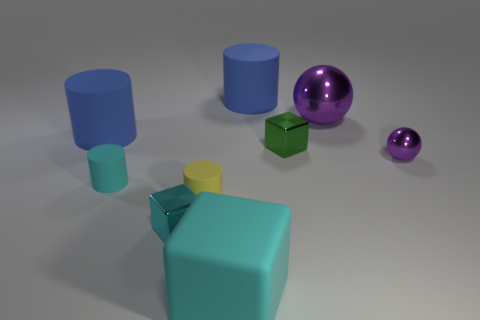Subtract all cyan cylinders. How many cylinders are left? 3 Add 1 cyan cubes. How many objects exist? 10 Subtract all green blocks. How many blocks are left? 2 Subtract 1 cylinders. How many cylinders are left? 3 Subtract all yellow spheres. Subtract all brown cylinders. How many spheres are left? 2 Subtract all red spheres. How many yellow cylinders are left? 1 Subtract all cyan rubber objects. Subtract all tiny yellow things. How many objects are left? 6 Add 5 small green blocks. How many small green blocks are left? 6 Add 8 small yellow cubes. How many small yellow cubes exist? 8 Subtract 1 purple balls. How many objects are left? 8 